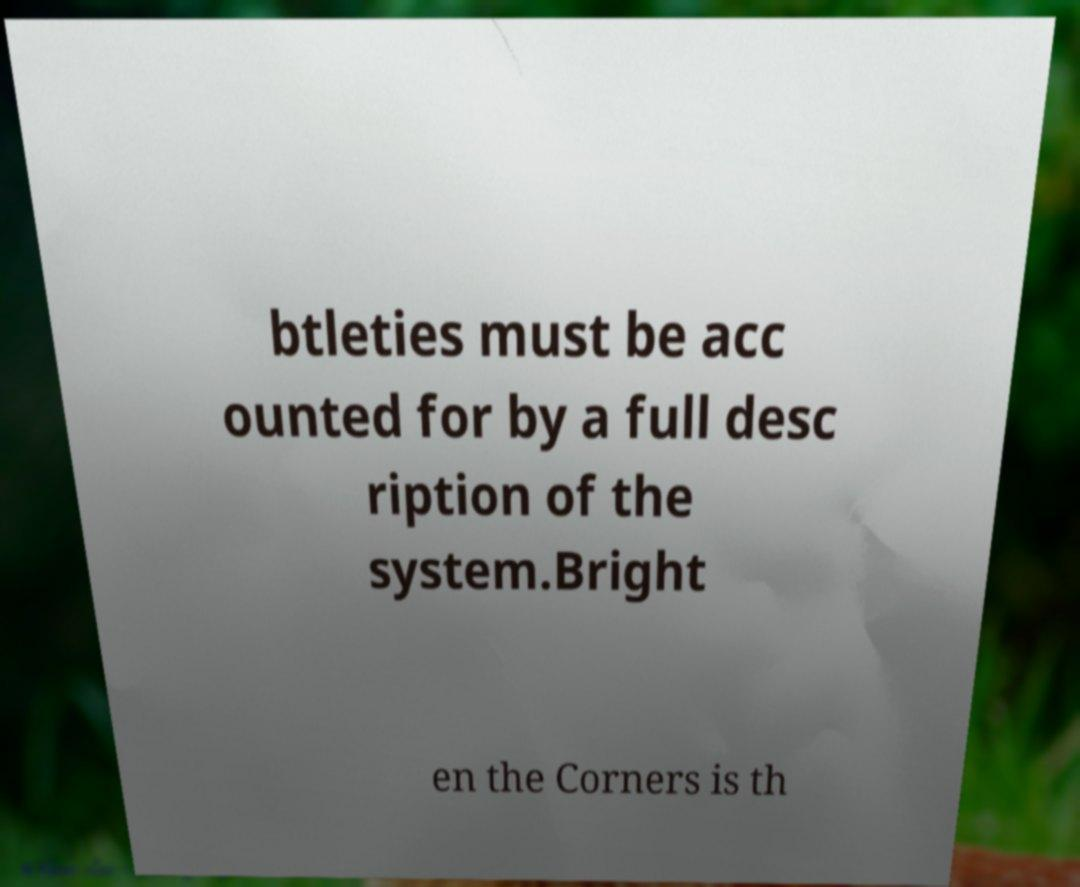There's text embedded in this image that I need extracted. Can you transcribe it verbatim? btleties must be acc ounted for by a full desc ription of the system.Bright en the Corners is th 